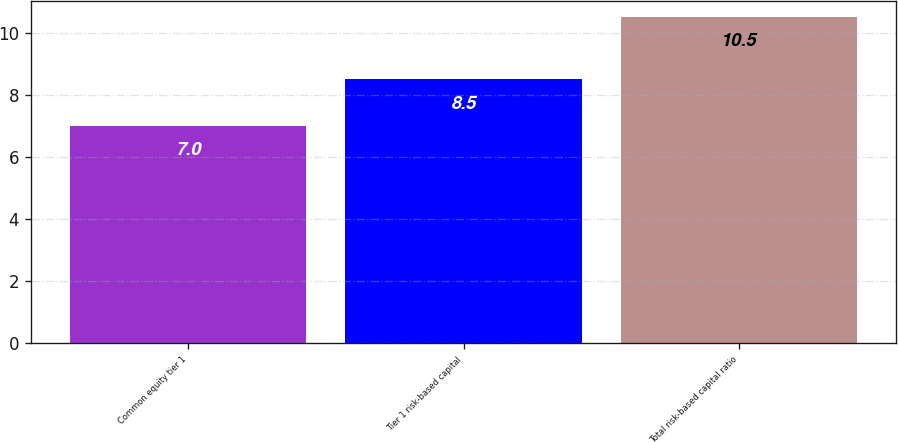<chart> <loc_0><loc_0><loc_500><loc_500><bar_chart><fcel>Common equity tier 1<fcel>Tier 1 risk-based capital<fcel>Total risk-based capital ratio<nl><fcel>7<fcel>8.5<fcel>10.5<nl></chart> 